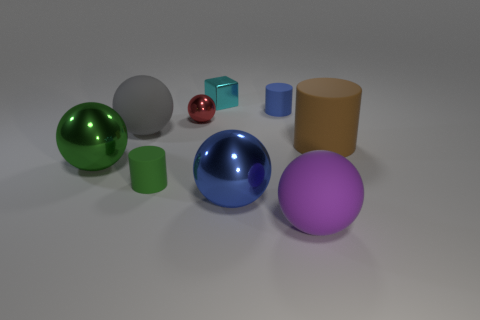Subtract all small cylinders. How many cylinders are left? 1 Subtract all blocks. How many objects are left? 8 Subtract 3 cylinders. How many cylinders are left? 0 Subtract all red balls. How many balls are left? 4 Subtract all brown cylinders. Subtract all purple spheres. How many cylinders are left? 2 Subtract all red spheres. How many brown cylinders are left? 1 Subtract all big yellow metal objects. Subtract all large gray spheres. How many objects are left? 8 Add 2 large brown cylinders. How many large brown cylinders are left? 3 Add 4 gray objects. How many gray objects exist? 5 Subtract 1 purple balls. How many objects are left? 8 